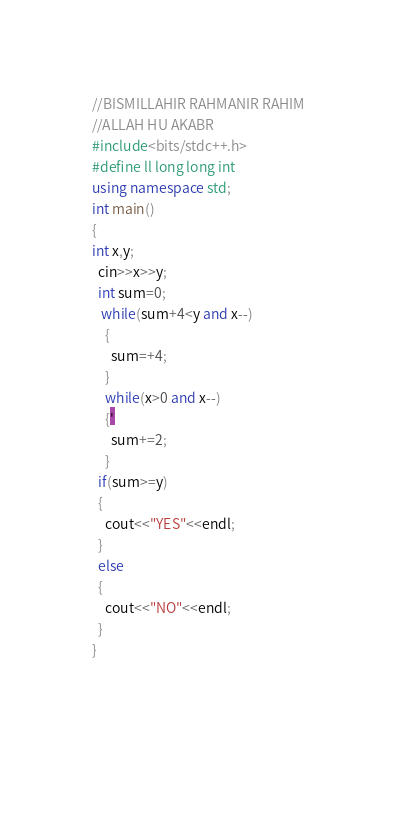Convert code to text. <code><loc_0><loc_0><loc_500><loc_500><_C++_>//BISMILLAHIR RAHMANIR RAHIM
//ALLAH HU AKABR
#include<bits/stdc++.h>
#define ll long long int
using namespace std;
int main()
{
int x,y;
  cin>>x>>y;
  int sum=0;
   while(sum+4<y and x--)
    {
      sum=+4;
    }
    while(x>0 and x--)
    {'
      sum+=2;
    }
  if(sum>=y)
  {
    cout<<"YES"<<endl;
  }
  else
  {
    cout<<"NO"<<endl;
  }
}
      
      
    </code> 